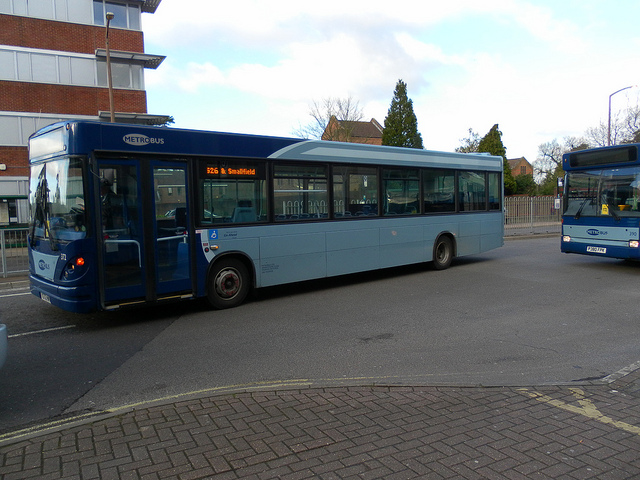Please extract the text content from this image. METROBUS 526 